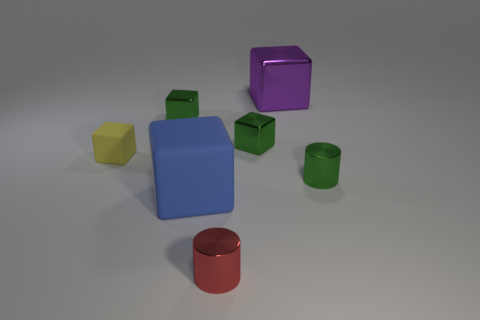What is the material of the small yellow object that is the same shape as the large shiny object?
Give a very brief answer. Rubber. What is the thing that is both behind the small red metal cylinder and in front of the green cylinder made of?
Provide a short and direct response. Rubber. What is the shape of the yellow thing that is made of the same material as the blue block?
Keep it short and to the point. Cube. Is the small cylinder that is behind the small red thing made of the same material as the green block that is on the right side of the large matte thing?
Your answer should be very brief. Yes. What material is the big blue object?
Provide a succinct answer. Rubber. Is the yellow thing made of the same material as the green cylinder?
Ensure brevity in your answer.  No. What number of metal things are tiny green blocks or big purple cubes?
Your answer should be compact. 3. The large object in front of the large metal object has what shape?
Ensure brevity in your answer.  Cube. There is another cylinder that is the same material as the small green cylinder; what size is it?
Ensure brevity in your answer.  Small. The object that is on the right side of the small rubber object and on the left side of the large rubber block has what shape?
Make the answer very short. Cube. 